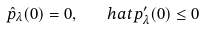<formula> <loc_0><loc_0><loc_500><loc_500>\hat { p } _ { \lambda } ( 0 ) = 0 , \ \ \ \ h a t { p } _ { \lambda } ^ { \prime } ( 0 ) \leq 0</formula> 